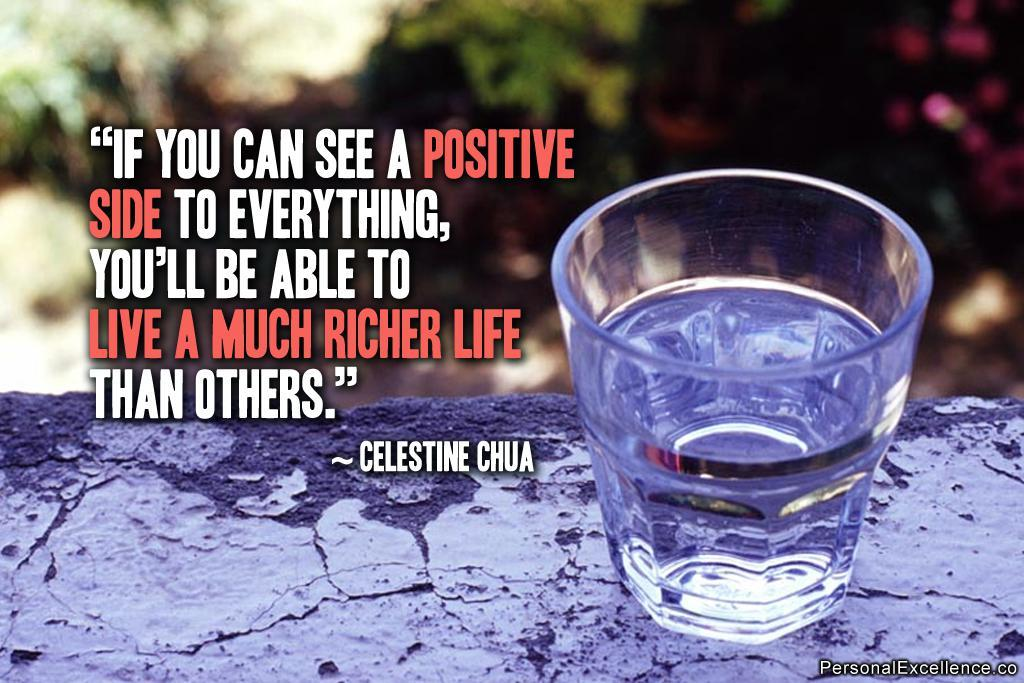<image>
Provide a brief description of the given image. A poster with a glass of water and a quote from Celestine Chua. 